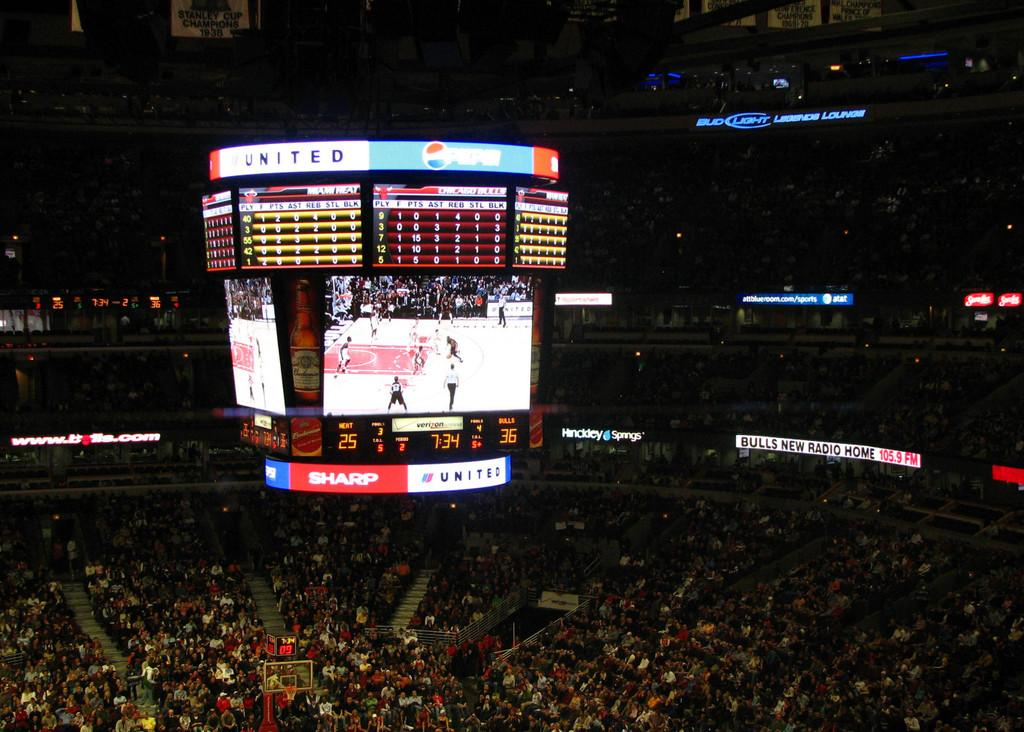<image>
Describe the image concisely. The score board at the stadium has ads for United And Pepsi going across the top. 